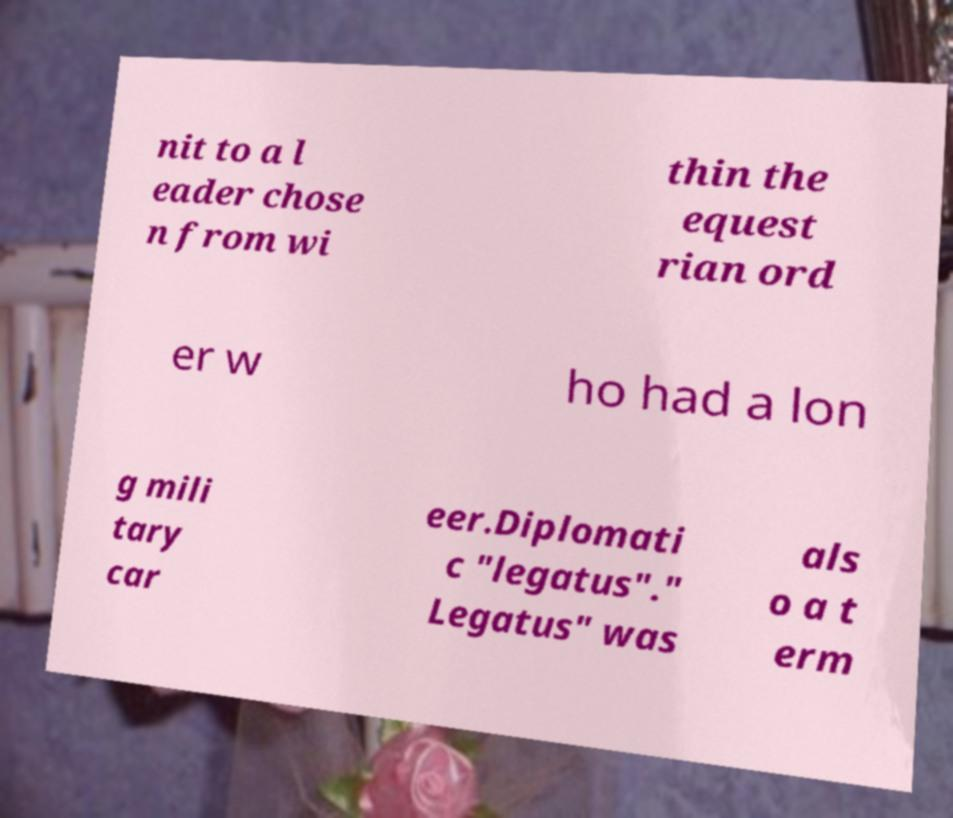Please identify and transcribe the text found in this image. nit to a l eader chose n from wi thin the equest rian ord er w ho had a lon g mili tary car eer.Diplomati c "legatus"." Legatus" was als o a t erm 